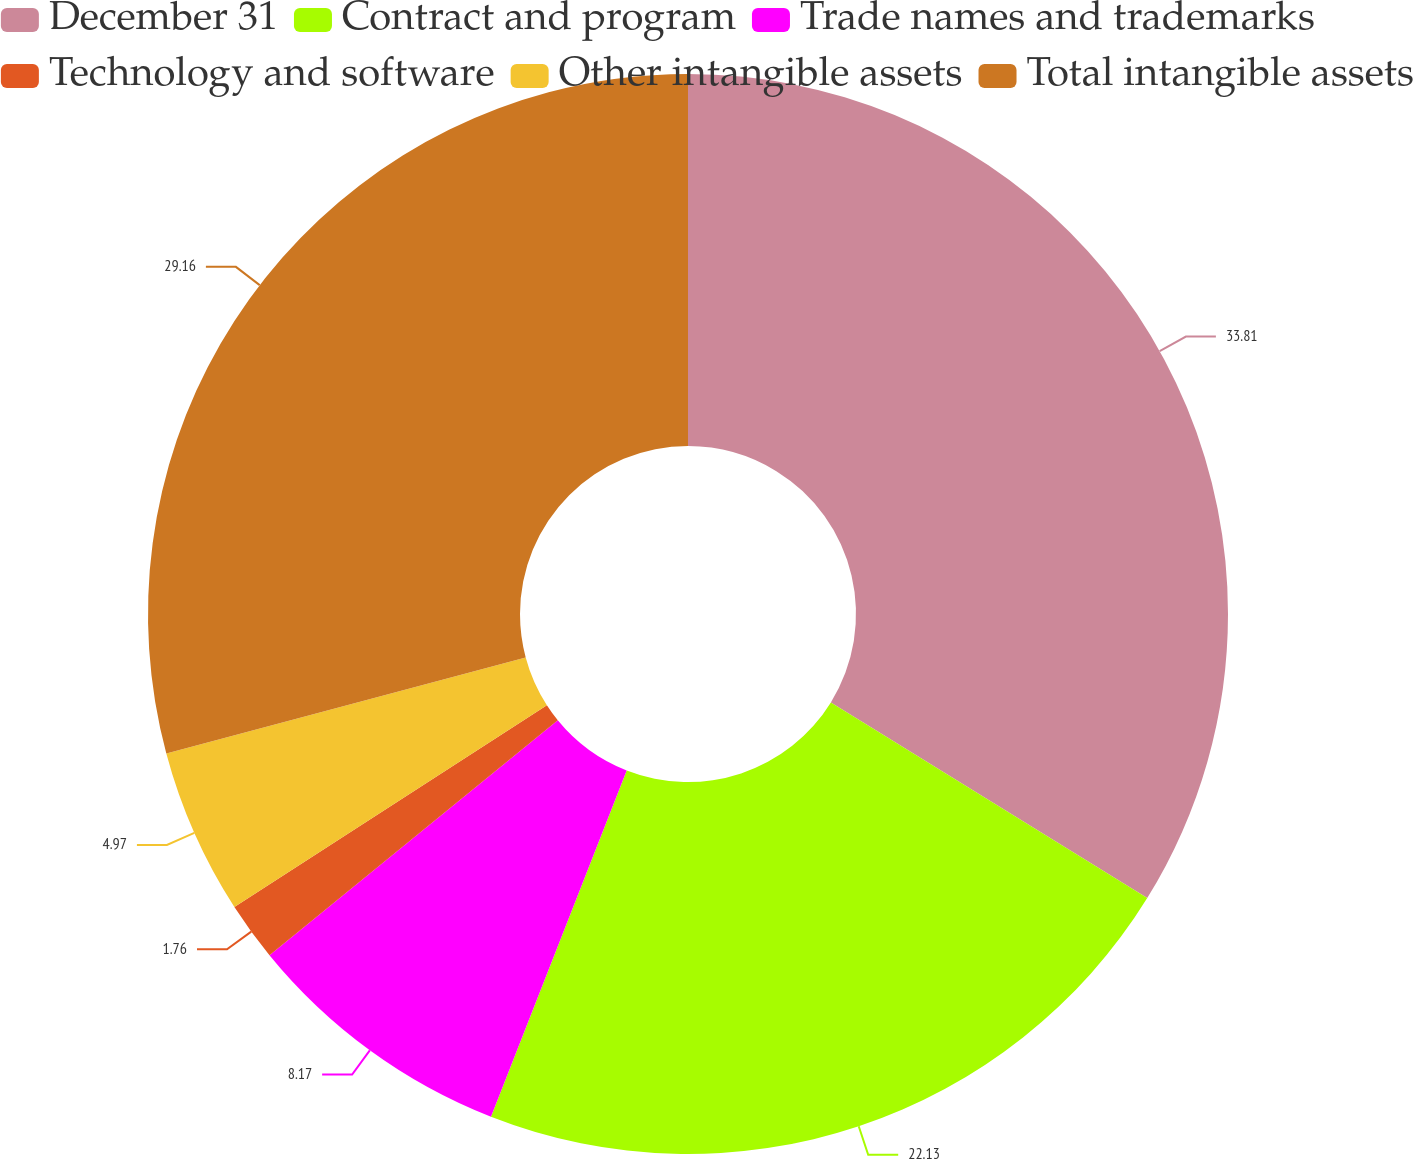Convert chart to OTSL. <chart><loc_0><loc_0><loc_500><loc_500><pie_chart><fcel>December 31<fcel>Contract and program<fcel>Trade names and trademarks<fcel>Technology and software<fcel>Other intangible assets<fcel>Total intangible assets<nl><fcel>33.82%<fcel>22.13%<fcel>8.17%<fcel>1.76%<fcel>4.97%<fcel>29.16%<nl></chart> 